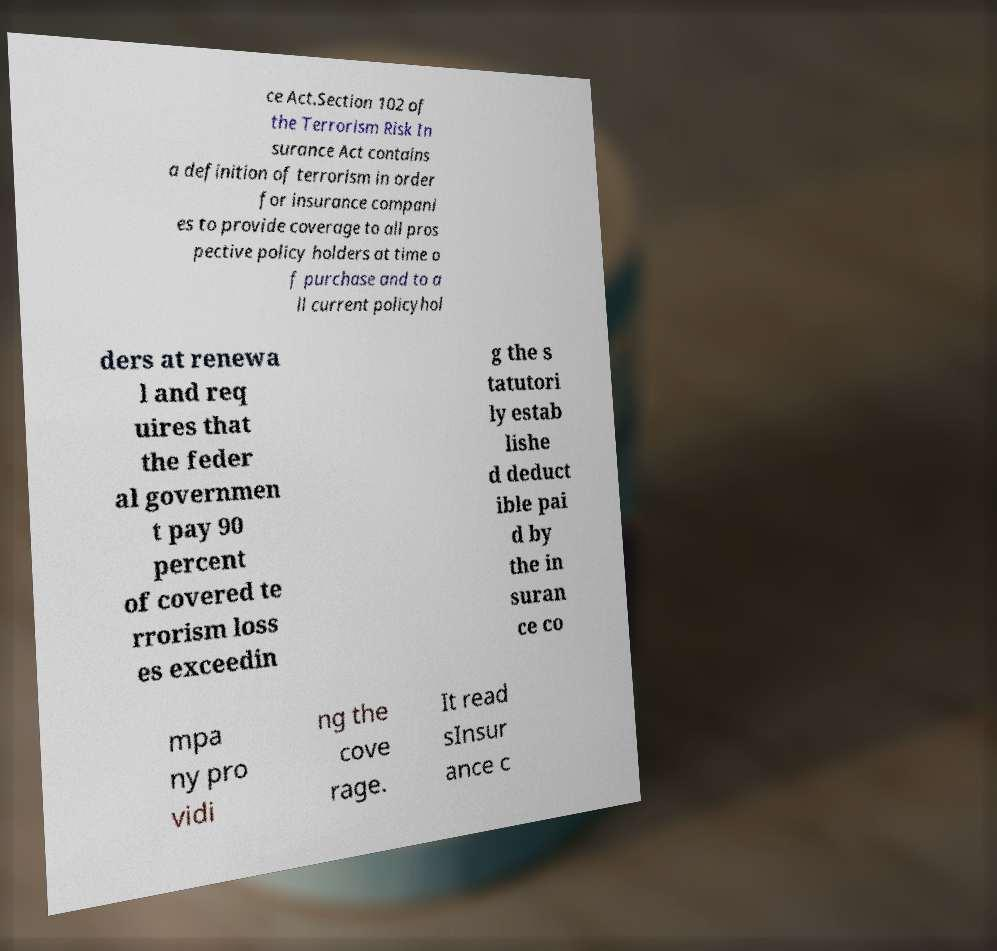For documentation purposes, I need the text within this image transcribed. Could you provide that? ce Act.Section 102 of the Terrorism Risk In surance Act contains a definition of terrorism in order for insurance compani es to provide coverage to all pros pective policy holders at time o f purchase and to a ll current policyhol ders at renewa l and req uires that the feder al governmen t pay 90 percent of covered te rrorism loss es exceedin g the s tatutori ly estab lishe d deduct ible pai d by the in suran ce co mpa ny pro vidi ng the cove rage. It read sInsur ance c 